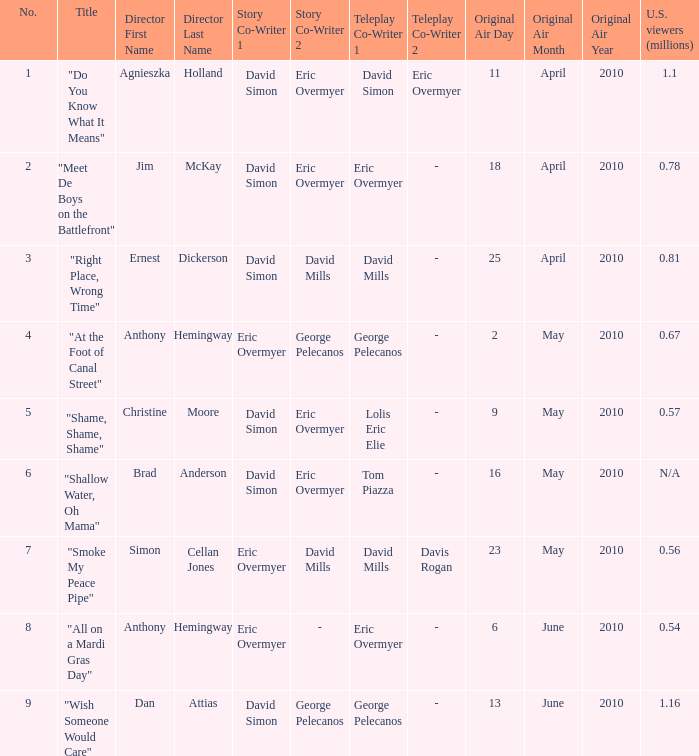Name the most number 9.0. 